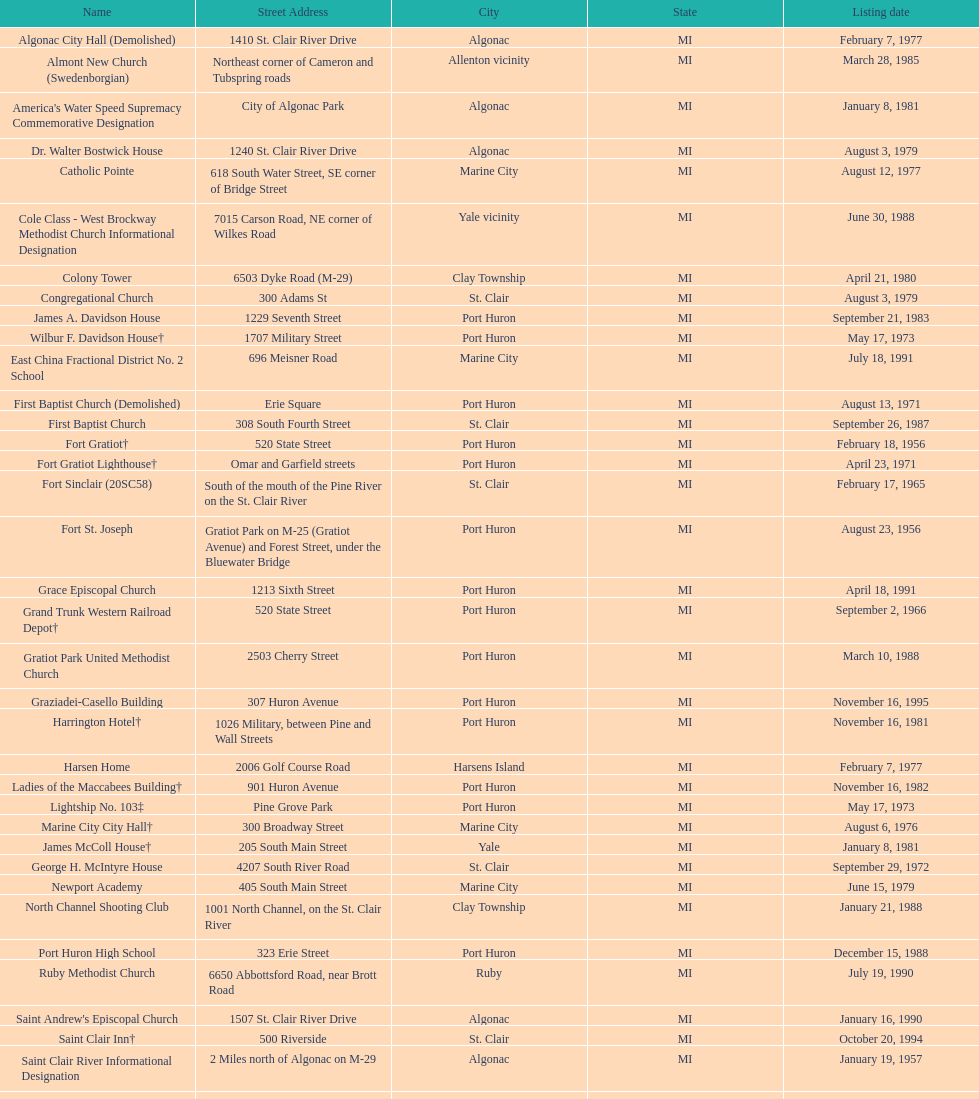How many names do not have images next to them? 41. 